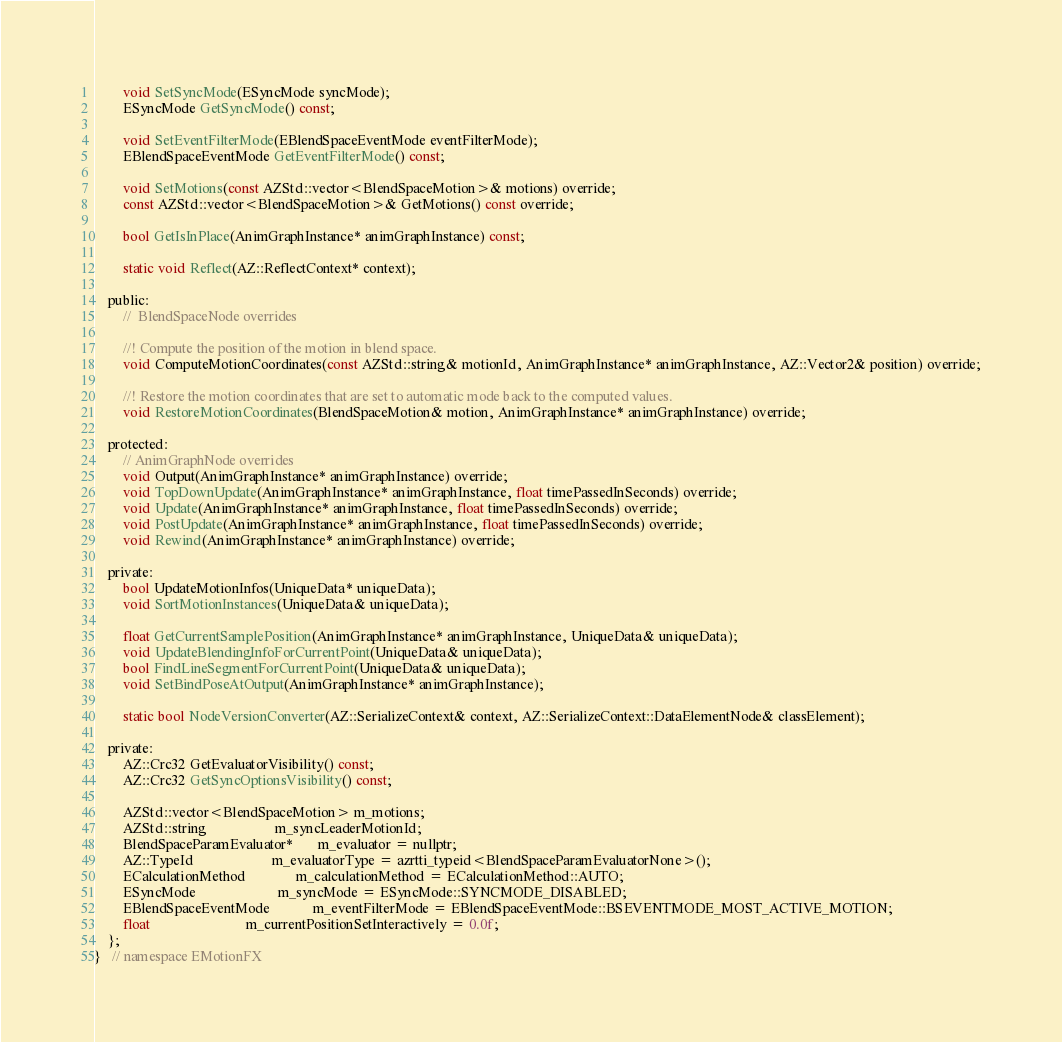<code> <loc_0><loc_0><loc_500><loc_500><_C_>
        void SetSyncMode(ESyncMode syncMode);
        ESyncMode GetSyncMode() const;

        void SetEventFilterMode(EBlendSpaceEventMode eventFilterMode);
        EBlendSpaceEventMode GetEventFilterMode() const;

        void SetMotions(const AZStd::vector<BlendSpaceMotion>& motions) override;
        const AZStd::vector<BlendSpaceMotion>& GetMotions() const override;

        bool GetIsInPlace(AnimGraphInstance* animGraphInstance) const;

        static void Reflect(AZ::ReflectContext* context);

    public:
        //  BlendSpaceNode overrides

        //! Compute the position of the motion in blend space.
        void ComputeMotionCoordinates(const AZStd::string& motionId, AnimGraphInstance* animGraphInstance, AZ::Vector2& position) override;

        //! Restore the motion coordinates that are set to automatic mode back to the computed values.
        void RestoreMotionCoordinates(BlendSpaceMotion& motion, AnimGraphInstance* animGraphInstance) override;

    protected:
        // AnimGraphNode overrides
        void Output(AnimGraphInstance* animGraphInstance) override;
        void TopDownUpdate(AnimGraphInstance* animGraphInstance, float timePassedInSeconds) override;
        void Update(AnimGraphInstance* animGraphInstance, float timePassedInSeconds) override;
        void PostUpdate(AnimGraphInstance* animGraphInstance, float timePassedInSeconds) override;
        void Rewind(AnimGraphInstance* animGraphInstance) override;

    private:
        bool UpdateMotionInfos(UniqueData* uniqueData);
        void SortMotionInstances(UniqueData& uniqueData);

        float GetCurrentSamplePosition(AnimGraphInstance* animGraphInstance, UniqueData& uniqueData);
        void UpdateBlendingInfoForCurrentPoint(UniqueData& uniqueData);
        bool FindLineSegmentForCurrentPoint(UniqueData& uniqueData);
        void SetBindPoseAtOutput(AnimGraphInstance* animGraphInstance);

        static bool NodeVersionConverter(AZ::SerializeContext& context, AZ::SerializeContext::DataElementNode& classElement);

    private:
        AZ::Crc32 GetEvaluatorVisibility() const;
        AZ::Crc32 GetSyncOptionsVisibility() const;

        AZStd::vector<BlendSpaceMotion> m_motions;
        AZStd::string                   m_syncLeaderMotionId;
        BlendSpaceParamEvaluator*       m_evaluator = nullptr;
        AZ::TypeId                      m_evaluatorType = azrtti_typeid<BlendSpaceParamEvaluatorNone>();
        ECalculationMethod              m_calculationMethod = ECalculationMethod::AUTO;
        ESyncMode                       m_syncMode = ESyncMode::SYNCMODE_DISABLED;
        EBlendSpaceEventMode            m_eventFilterMode = EBlendSpaceEventMode::BSEVENTMODE_MOST_ACTIVE_MOTION;
        float                           m_currentPositionSetInteractively = 0.0f;
    };
}   // namespace EMotionFX
</code> 